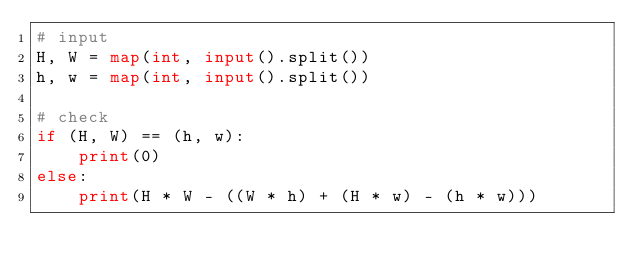<code> <loc_0><loc_0><loc_500><loc_500><_Python_># input
H, W = map(int, input().split())
h, w = map(int, input().split())

# check
if (H, W) == (h, w):
    print(0)
else:
    print(H * W - ((W * h) + (H * w) - (h * w)))</code> 